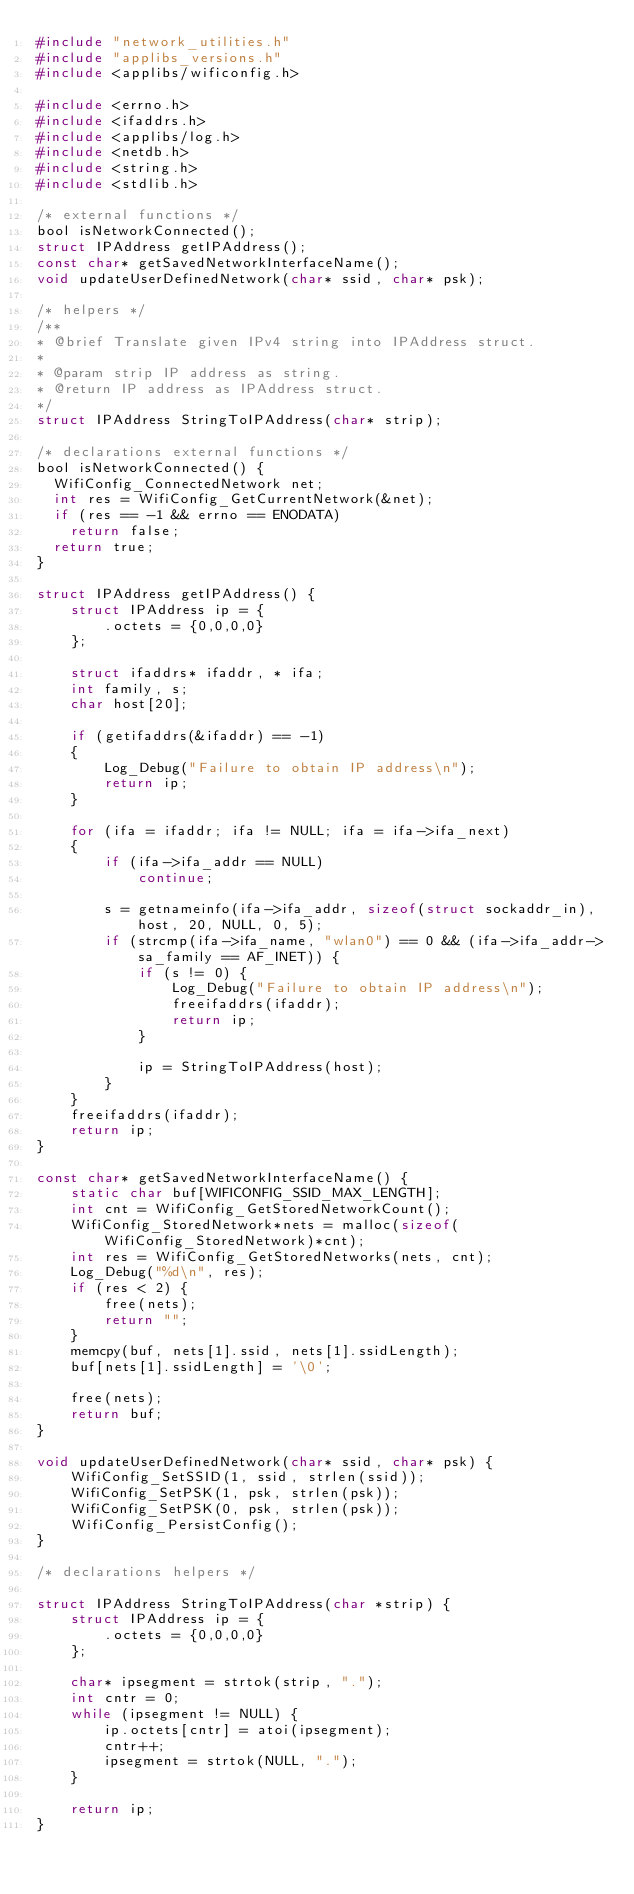Convert code to text. <code><loc_0><loc_0><loc_500><loc_500><_C_>#include "network_utilities.h"
#include "applibs_versions.h"
#include <applibs/wificonfig.h>

#include <errno.h>
#include <ifaddrs.h>
#include <applibs/log.h>
#include <netdb.h>
#include <string.h>
#include <stdlib.h>

/* external functions */
bool isNetworkConnected();
struct IPAddress getIPAddress();
const char* getSavedNetworkInterfaceName();
void updateUserDefinedNetwork(char* ssid, char* psk);

/* helpers */
/**
* @brief Translate given IPv4 string into IPAddress struct.
*
* @param strip IP address as string.
* @return IP address as IPAddress struct.
*/
struct IPAddress StringToIPAddress(char* strip);

/* declarations external functions */
bool isNetworkConnected() {
	WifiConfig_ConnectedNetwork net;
	int res = WifiConfig_GetCurrentNetwork(&net);
	if (res == -1 && errno == ENODATA)
		return false;
	return true;
}

struct IPAddress getIPAddress() {
    struct IPAddress ip = {
        .octets = {0,0,0,0}
    };

    struct ifaddrs* ifaddr, * ifa;
    int family, s;
    char host[20];

    if (getifaddrs(&ifaddr) == -1)
    {
        Log_Debug("Failure to obtain IP address\n");
        return ip;
    }

    for (ifa = ifaddr; ifa != NULL; ifa = ifa->ifa_next)
    {
        if (ifa->ifa_addr == NULL)
            continue;

        s = getnameinfo(ifa->ifa_addr, sizeof(struct sockaddr_in), host, 20, NULL, 0, 5);
        if (strcmp(ifa->ifa_name, "wlan0") == 0 && (ifa->ifa_addr->sa_family == AF_INET)) {
            if (s != 0) {
                Log_Debug("Failure to obtain IP address\n");
                freeifaddrs(ifaddr);
                return ip;
            }
            
            ip = StringToIPAddress(host);
        }
    }
    freeifaddrs(ifaddr);
    return ip;
}

const char* getSavedNetworkInterfaceName() {
    static char buf[WIFICONFIG_SSID_MAX_LENGTH];
    int cnt = WifiConfig_GetStoredNetworkCount();
    WifiConfig_StoredNetwork*nets = malloc(sizeof(WifiConfig_StoredNetwork)*cnt);
    int res = WifiConfig_GetStoredNetworks(nets, cnt);
    Log_Debug("%d\n", res);
    if (res < 2) {
        free(nets);
        return "";
    }
    memcpy(buf, nets[1].ssid, nets[1].ssidLength);
    buf[nets[1].ssidLength] = '\0';

    free(nets);
    return buf;
}

void updateUserDefinedNetwork(char* ssid, char* psk) {
    WifiConfig_SetSSID(1, ssid, strlen(ssid));
    WifiConfig_SetPSK(1, psk, strlen(psk));
    WifiConfig_SetPSK(0, psk, strlen(psk));
    WifiConfig_PersistConfig();
}

/* declarations helpers */

struct IPAddress StringToIPAddress(char *strip) {
    struct IPAddress ip = {
        .octets = {0,0,0,0}
    };

    char* ipsegment = strtok(strip, ".");
    int cntr = 0;
    while (ipsegment != NULL) {
        ip.octets[cntr] = atoi(ipsegment);
        cntr++;
        ipsegment = strtok(NULL, ".");
    }

    return ip;
}</code> 